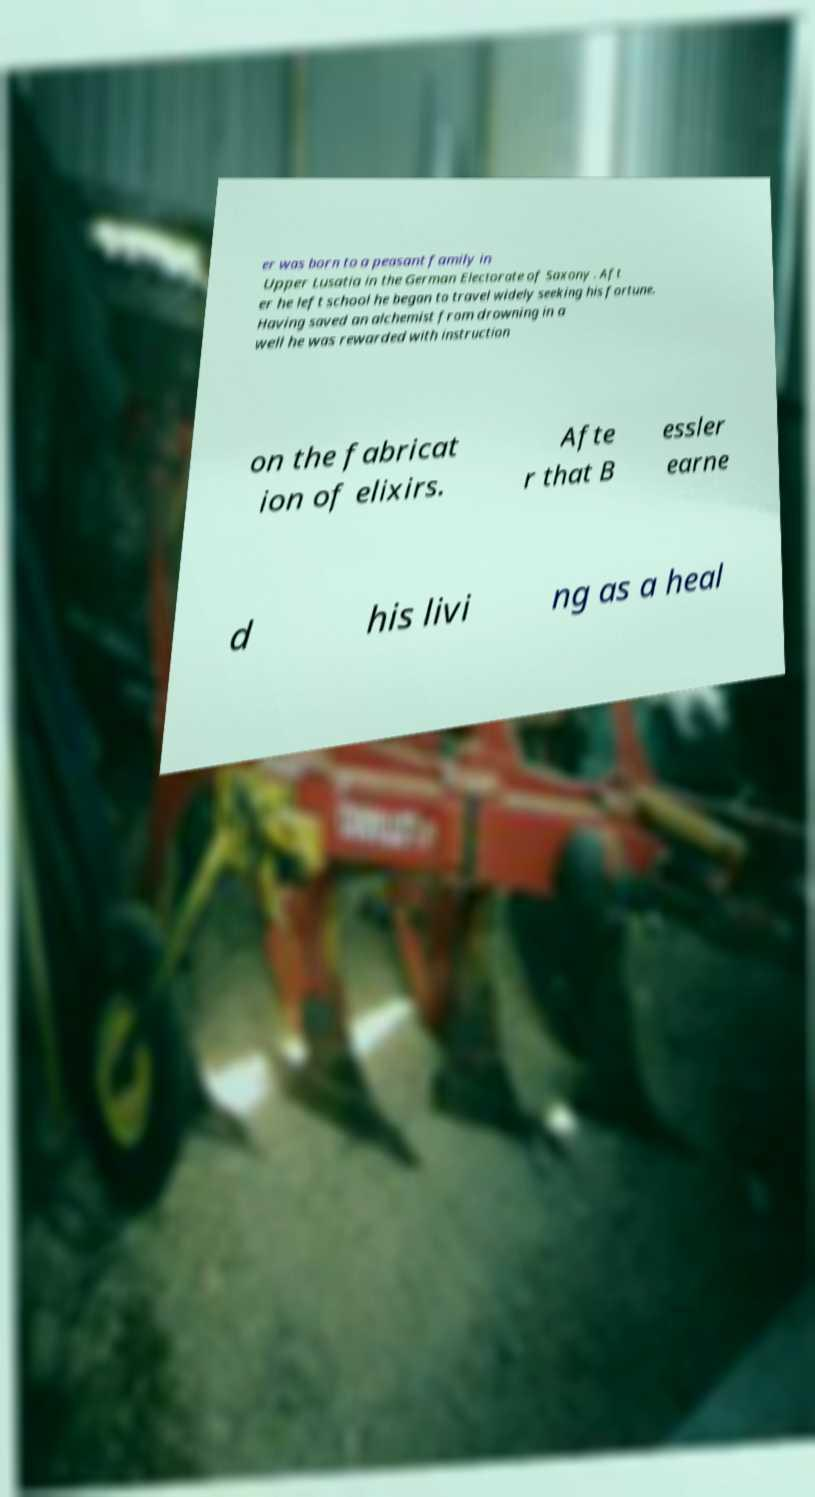I need the written content from this picture converted into text. Can you do that? er was born to a peasant family in Upper Lusatia in the German Electorate of Saxony . Aft er he left school he began to travel widely seeking his fortune. Having saved an alchemist from drowning in a well he was rewarded with instruction on the fabricat ion of elixirs. Afte r that B essler earne d his livi ng as a heal 